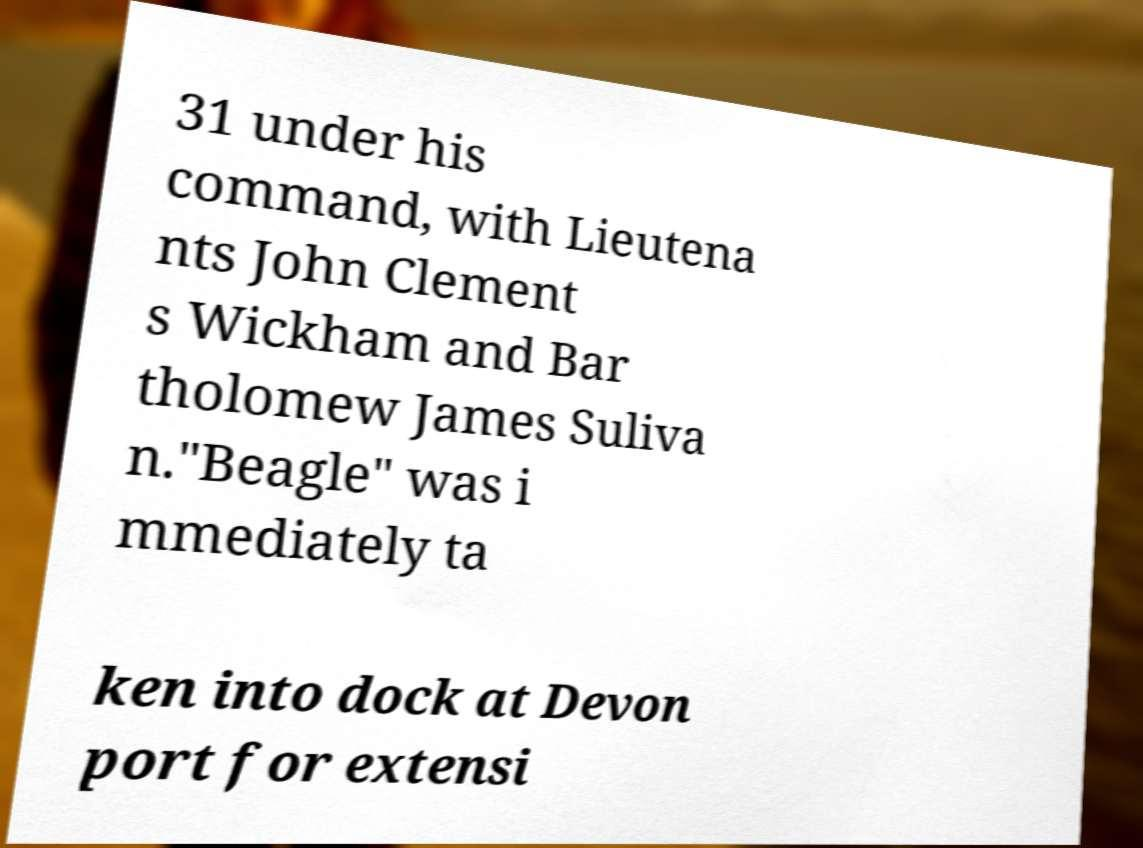Please identify and transcribe the text found in this image. 31 under his command, with Lieutena nts John Clement s Wickham and Bar tholomew James Suliva n."Beagle" was i mmediately ta ken into dock at Devon port for extensi 